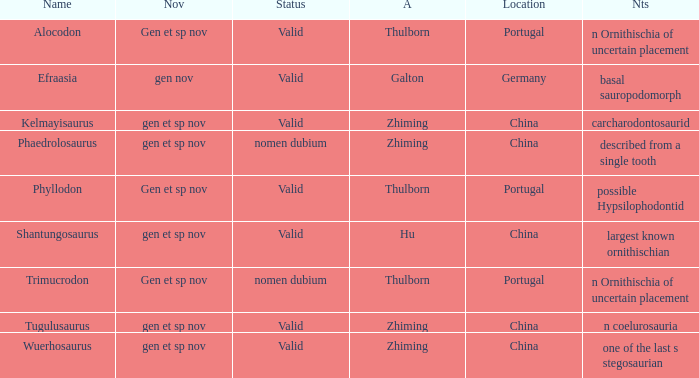What is the Status of the dinosaur, whose notes are, "n coelurosauria"? Valid. 